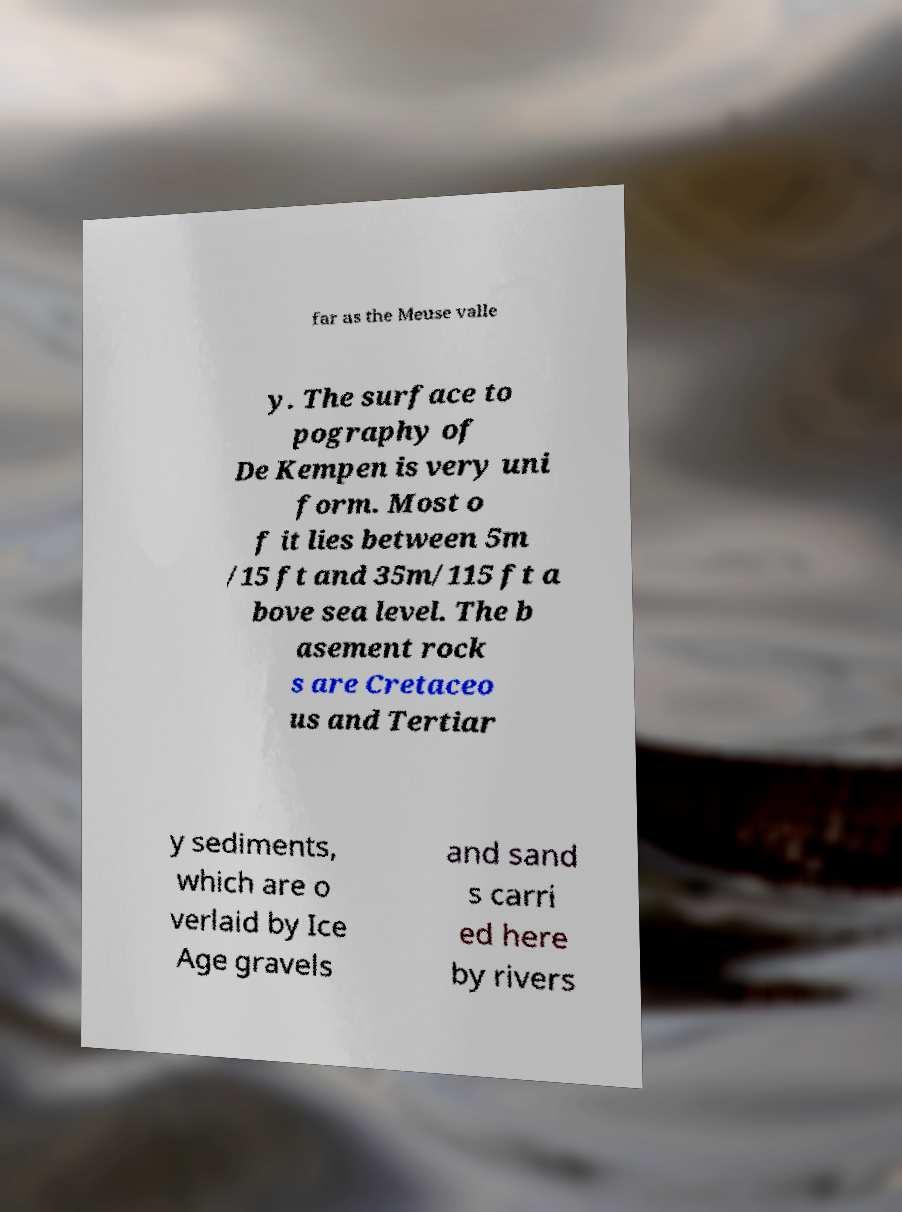Could you assist in decoding the text presented in this image and type it out clearly? far as the Meuse valle y. The surface to pography of De Kempen is very uni form. Most o f it lies between 5m /15 ft and 35m/115 ft a bove sea level. The b asement rock s are Cretaceo us and Tertiar y sediments, which are o verlaid by Ice Age gravels and sand s carri ed here by rivers 